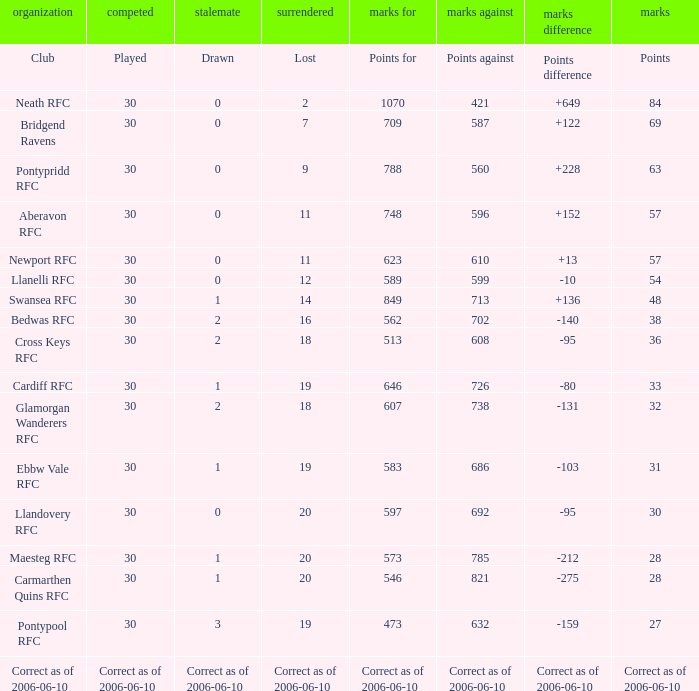Could you help me parse every detail presented in this table? {'header': ['organization', 'competed', 'stalemate', 'surrendered', 'marks for', 'marks against', 'marks difference', 'marks'], 'rows': [['Club', 'Played', 'Drawn', 'Lost', 'Points for', 'Points against', 'Points difference', 'Points'], ['Neath RFC', '30', '0', '2', '1070', '421', '+649', '84'], ['Bridgend Ravens', '30', '0', '7', '709', '587', '+122', '69'], ['Pontypridd RFC', '30', '0', '9', '788', '560', '+228', '63'], ['Aberavon RFC', '30', '0', '11', '748', '596', '+152', '57'], ['Newport RFC', '30', '0', '11', '623', '610', '+13', '57'], ['Llanelli RFC', '30', '0', '12', '589', '599', '-10', '54'], ['Swansea RFC', '30', '1', '14', '849', '713', '+136', '48'], ['Bedwas RFC', '30', '2', '16', '562', '702', '-140', '38'], ['Cross Keys RFC', '30', '2', '18', '513', '608', '-95', '36'], ['Cardiff RFC', '30', '1', '19', '646', '726', '-80', '33'], ['Glamorgan Wanderers RFC', '30', '2', '18', '607', '738', '-131', '32'], ['Ebbw Vale RFC', '30', '1', '19', '583', '686', '-103', '31'], ['Llandovery RFC', '30', '0', '20', '597', '692', '-95', '30'], ['Maesteg RFC', '30', '1', '20', '573', '785', '-212', '28'], ['Carmarthen Quins RFC', '30', '1', '20', '546', '821', '-275', '28'], ['Pontypool RFC', '30', '3', '19', '473', '632', '-159', '27'], ['Correct as of 2006-06-10', 'Correct as of 2006-06-10', 'Correct as of 2006-06-10', 'Correct as of 2006-06-10', 'Correct as of 2006-06-10', 'Correct as of 2006-06-10', 'Correct as of 2006-06-10', 'Correct as of 2006-06-10']]} What is Points Against, when Drawn is "2", and when Points Of is "32"? 738.0. 